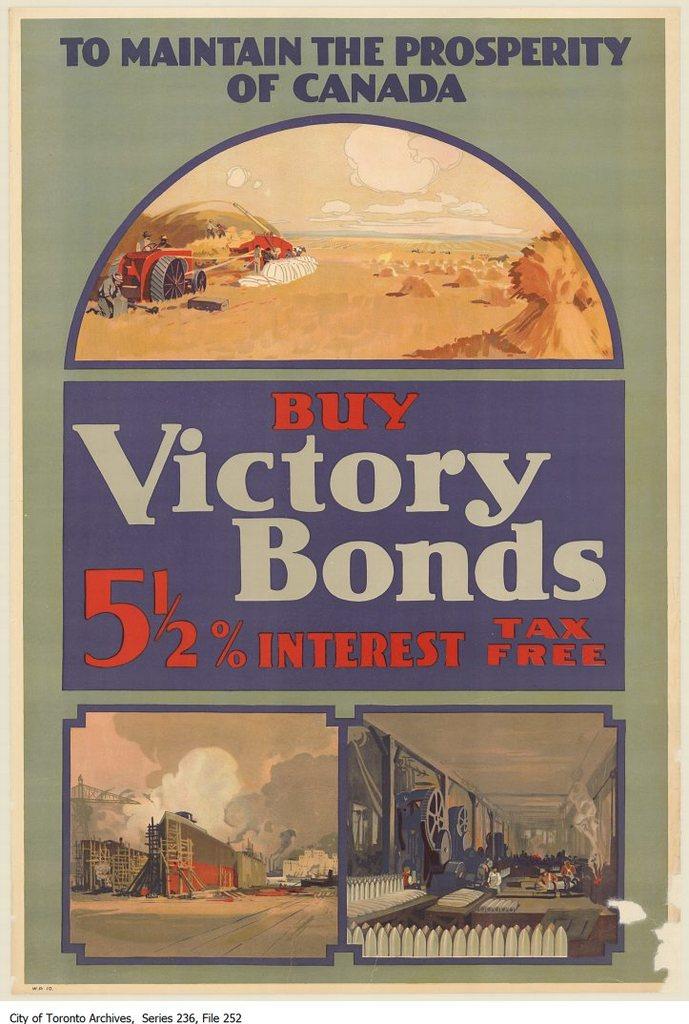What country sells these bonds?
Your answer should be compact. Canada. 